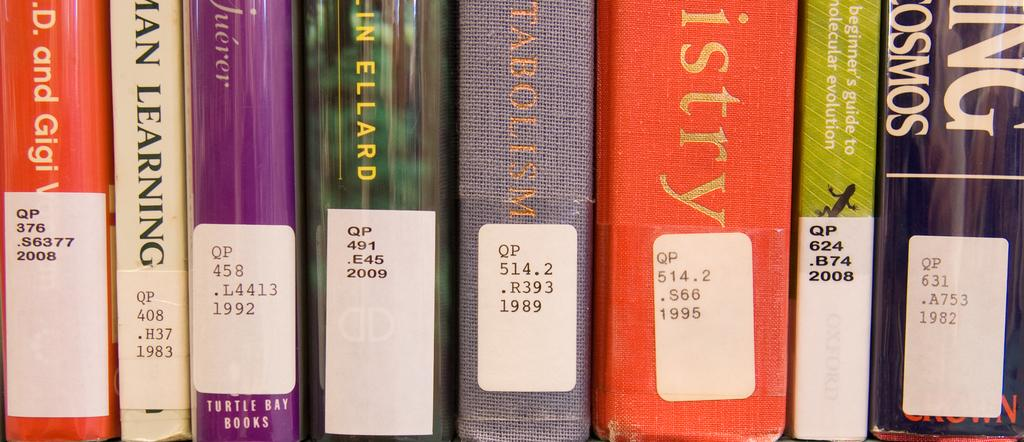<image>
Create a compact narrative representing the image presented. Several books are lined up next to each other and the first one on the left has a sticker on it that reads WP376.S63772008 